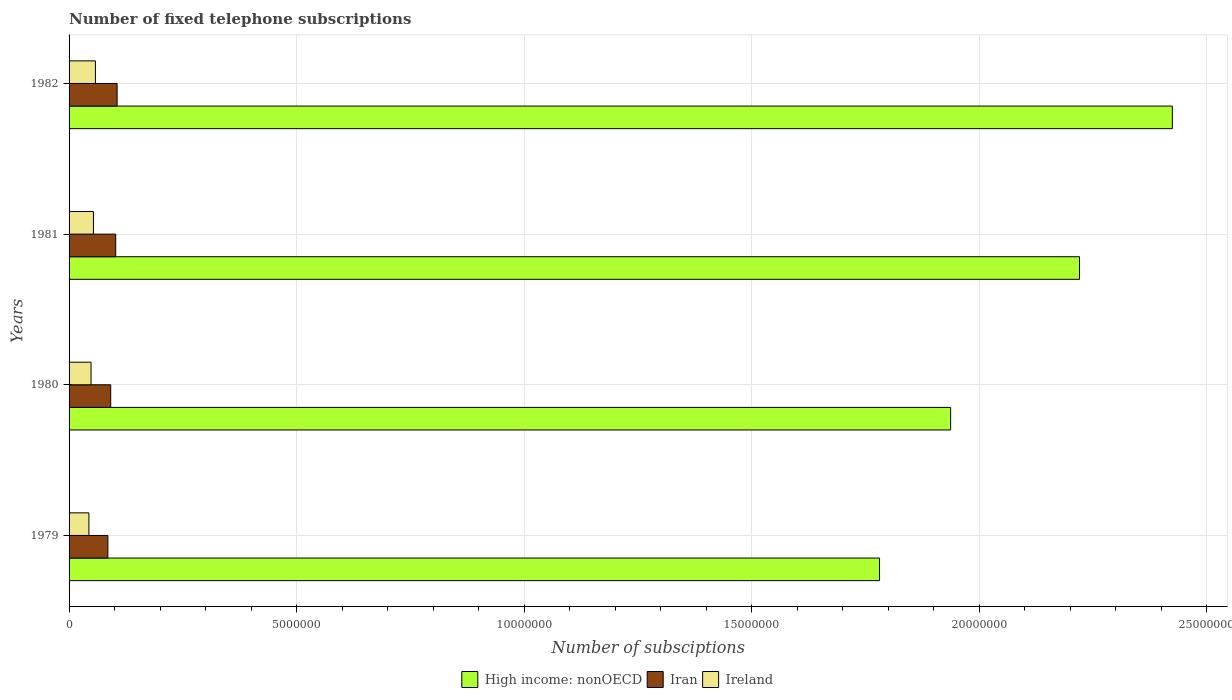How many different coloured bars are there?
Your answer should be compact. 3. Are the number of bars per tick equal to the number of legend labels?
Offer a very short reply. Yes. Are the number of bars on each tick of the Y-axis equal?
Offer a very short reply. Yes. How many bars are there on the 4th tick from the top?
Provide a succinct answer. 3. How many bars are there on the 3rd tick from the bottom?
Offer a terse response. 3. What is the label of the 4th group of bars from the top?
Provide a succinct answer. 1979. In how many cases, is the number of bars for a given year not equal to the number of legend labels?
Your answer should be very brief. 0. What is the number of fixed telephone subscriptions in High income: nonOECD in 1980?
Provide a succinct answer. 1.94e+07. Across all years, what is the maximum number of fixed telephone subscriptions in High income: nonOECD?
Provide a short and direct response. 2.42e+07. Across all years, what is the minimum number of fixed telephone subscriptions in High income: nonOECD?
Your answer should be very brief. 1.78e+07. In which year was the number of fixed telephone subscriptions in High income: nonOECD maximum?
Ensure brevity in your answer.  1982. In which year was the number of fixed telephone subscriptions in Iran minimum?
Keep it short and to the point. 1979. What is the total number of fixed telephone subscriptions in Ireland in the graph?
Your answer should be compact. 2.03e+06. What is the difference between the number of fixed telephone subscriptions in Ireland in 1981 and that in 1982?
Offer a terse response. -4.36e+04. What is the difference between the number of fixed telephone subscriptions in Iran in 1981 and the number of fixed telephone subscriptions in Ireland in 1979?
Offer a terse response. 5.89e+05. What is the average number of fixed telephone subscriptions in High income: nonOECD per year?
Keep it short and to the point. 2.09e+07. In the year 1980, what is the difference between the number of fixed telephone subscriptions in Ireland and number of fixed telephone subscriptions in High income: nonOECD?
Offer a terse response. -1.89e+07. What is the ratio of the number of fixed telephone subscriptions in Iran in 1981 to that in 1982?
Ensure brevity in your answer.  0.97. Is the number of fixed telephone subscriptions in Iran in 1980 less than that in 1981?
Keep it short and to the point. Yes. Is the difference between the number of fixed telephone subscriptions in Ireland in 1981 and 1982 greater than the difference between the number of fixed telephone subscriptions in High income: nonOECD in 1981 and 1982?
Give a very brief answer. Yes. What is the difference between the highest and the second highest number of fixed telephone subscriptions in Iran?
Your answer should be very brief. 3.07e+04. What is the difference between the highest and the lowest number of fixed telephone subscriptions in Iran?
Make the answer very short. 2.03e+05. In how many years, is the number of fixed telephone subscriptions in Iran greater than the average number of fixed telephone subscriptions in Iran taken over all years?
Give a very brief answer. 2. What does the 1st bar from the top in 1979 represents?
Make the answer very short. Ireland. What does the 3rd bar from the bottom in 1980 represents?
Provide a short and direct response. Ireland. Is it the case that in every year, the sum of the number of fixed telephone subscriptions in Iran and number of fixed telephone subscriptions in Ireland is greater than the number of fixed telephone subscriptions in High income: nonOECD?
Provide a short and direct response. No. How many bars are there?
Your response must be concise. 12. Are all the bars in the graph horizontal?
Ensure brevity in your answer.  Yes. What is the difference between two consecutive major ticks on the X-axis?
Make the answer very short. 5.00e+06. What is the title of the graph?
Keep it short and to the point. Number of fixed telephone subscriptions. Does "Montenegro" appear as one of the legend labels in the graph?
Keep it short and to the point. No. What is the label or title of the X-axis?
Your answer should be very brief. Number of subsciptions. What is the label or title of the Y-axis?
Provide a succinct answer. Years. What is the Number of subsciptions of High income: nonOECD in 1979?
Provide a short and direct response. 1.78e+07. What is the Number of subsciptions in Iran in 1979?
Your answer should be compact. 8.53e+05. What is the Number of subsciptions in Ireland in 1979?
Keep it short and to the point. 4.36e+05. What is the Number of subsciptions in High income: nonOECD in 1980?
Provide a succinct answer. 1.94e+07. What is the Number of subsciptions of Iran in 1980?
Your answer should be very brief. 9.15e+05. What is the Number of subsciptions in Ireland in 1980?
Your answer should be very brief. 4.83e+05. What is the Number of subsciptions in High income: nonOECD in 1981?
Keep it short and to the point. 2.22e+07. What is the Number of subsciptions of Iran in 1981?
Ensure brevity in your answer.  1.03e+06. What is the Number of subsciptions in Ireland in 1981?
Offer a terse response. 5.36e+05. What is the Number of subsciptions of High income: nonOECD in 1982?
Offer a terse response. 2.42e+07. What is the Number of subsciptions of Iran in 1982?
Provide a succinct answer. 1.06e+06. What is the Number of subsciptions of Ireland in 1982?
Your answer should be compact. 5.80e+05. Across all years, what is the maximum Number of subsciptions of High income: nonOECD?
Provide a succinct answer. 2.42e+07. Across all years, what is the maximum Number of subsciptions in Iran?
Your response must be concise. 1.06e+06. Across all years, what is the maximum Number of subsciptions of Ireland?
Provide a succinct answer. 5.80e+05. Across all years, what is the minimum Number of subsciptions of High income: nonOECD?
Keep it short and to the point. 1.78e+07. Across all years, what is the minimum Number of subsciptions in Iran?
Give a very brief answer. 8.53e+05. Across all years, what is the minimum Number of subsciptions of Ireland?
Ensure brevity in your answer.  4.36e+05. What is the total Number of subsciptions of High income: nonOECD in the graph?
Offer a very short reply. 8.36e+07. What is the total Number of subsciptions of Iran in the graph?
Provide a succinct answer. 3.85e+06. What is the total Number of subsciptions in Ireland in the graph?
Provide a succinct answer. 2.03e+06. What is the difference between the Number of subsciptions in High income: nonOECD in 1979 and that in 1980?
Ensure brevity in your answer.  -1.56e+06. What is the difference between the Number of subsciptions in Iran in 1979 and that in 1980?
Keep it short and to the point. -6.23e+04. What is the difference between the Number of subsciptions of Ireland in 1979 and that in 1980?
Provide a succinct answer. -4.70e+04. What is the difference between the Number of subsciptions of High income: nonOECD in 1979 and that in 1981?
Keep it short and to the point. -4.40e+06. What is the difference between the Number of subsciptions of Iran in 1979 and that in 1981?
Ensure brevity in your answer.  -1.72e+05. What is the difference between the Number of subsciptions in Ireland in 1979 and that in 1981?
Your answer should be very brief. -1.00e+05. What is the difference between the Number of subsciptions of High income: nonOECD in 1979 and that in 1982?
Your answer should be very brief. -6.44e+06. What is the difference between the Number of subsciptions of Iran in 1979 and that in 1982?
Ensure brevity in your answer.  -2.03e+05. What is the difference between the Number of subsciptions of Ireland in 1979 and that in 1982?
Give a very brief answer. -1.44e+05. What is the difference between the Number of subsciptions in High income: nonOECD in 1980 and that in 1981?
Make the answer very short. -2.83e+06. What is the difference between the Number of subsciptions of Iran in 1980 and that in 1981?
Your answer should be compact. -1.10e+05. What is the difference between the Number of subsciptions of Ireland in 1980 and that in 1981?
Your answer should be very brief. -5.30e+04. What is the difference between the Number of subsciptions of High income: nonOECD in 1980 and that in 1982?
Provide a short and direct response. -4.87e+06. What is the difference between the Number of subsciptions in Iran in 1980 and that in 1982?
Provide a short and direct response. -1.41e+05. What is the difference between the Number of subsciptions in Ireland in 1980 and that in 1982?
Provide a succinct answer. -9.66e+04. What is the difference between the Number of subsciptions of High income: nonOECD in 1981 and that in 1982?
Provide a succinct answer. -2.04e+06. What is the difference between the Number of subsciptions of Iran in 1981 and that in 1982?
Give a very brief answer. -3.07e+04. What is the difference between the Number of subsciptions of Ireland in 1981 and that in 1982?
Make the answer very short. -4.36e+04. What is the difference between the Number of subsciptions in High income: nonOECD in 1979 and the Number of subsciptions in Iran in 1980?
Your answer should be compact. 1.69e+07. What is the difference between the Number of subsciptions of High income: nonOECD in 1979 and the Number of subsciptions of Ireland in 1980?
Provide a short and direct response. 1.73e+07. What is the difference between the Number of subsciptions of Iran in 1979 and the Number of subsciptions of Ireland in 1980?
Your answer should be compact. 3.70e+05. What is the difference between the Number of subsciptions of High income: nonOECD in 1979 and the Number of subsciptions of Iran in 1981?
Keep it short and to the point. 1.68e+07. What is the difference between the Number of subsciptions of High income: nonOECD in 1979 and the Number of subsciptions of Ireland in 1981?
Your answer should be compact. 1.73e+07. What is the difference between the Number of subsciptions of Iran in 1979 and the Number of subsciptions of Ireland in 1981?
Make the answer very short. 3.17e+05. What is the difference between the Number of subsciptions of High income: nonOECD in 1979 and the Number of subsciptions of Iran in 1982?
Provide a succinct answer. 1.68e+07. What is the difference between the Number of subsciptions of High income: nonOECD in 1979 and the Number of subsciptions of Ireland in 1982?
Your response must be concise. 1.72e+07. What is the difference between the Number of subsciptions of Iran in 1979 and the Number of subsciptions of Ireland in 1982?
Provide a short and direct response. 2.73e+05. What is the difference between the Number of subsciptions of High income: nonOECD in 1980 and the Number of subsciptions of Iran in 1981?
Your answer should be very brief. 1.84e+07. What is the difference between the Number of subsciptions of High income: nonOECD in 1980 and the Number of subsciptions of Ireland in 1981?
Your answer should be compact. 1.88e+07. What is the difference between the Number of subsciptions of Iran in 1980 and the Number of subsciptions of Ireland in 1981?
Ensure brevity in your answer.  3.79e+05. What is the difference between the Number of subsciptions in High income: nonOECD in 1980 and the Number of subsciptions in Iran in 1982?
Your answer should be very brief. 1.83e+07. What is the difference between the Number of subsciptions in High income: nonOECD in 1980 and the Number of subsciptions in Ireland in 1982?
Provide a succinct answer. 1.88e+07. What is the difference between the Number of subsciptions of Iran in 1980 and the Number of subsciptions of Ireland in 1982?
Ensure brevity in your answer.  3.36e+05. What is the difference between the Number of subsciptions in High income: nonOECD in 1981 and the Number of subsciptions in Iran in 1982?
Provide a succinct answer. 2.12e+07. What is the difference between the Number of subsciptions in High income: nonOECD in 1981 and the Number of subsciptions in Ireland in 1982?
Your answer should be compact. 2.16e+07. What is the difference between the Number of subsciptions of Iran in 1981 and the Number of subsciptions of Ireland in 1982?
Give a very brief answer. 4.45e+05. What is the average Number of subsciptions in High income: nonOECD per year?
Your response must be concise. 2.09e+07. What is the average Number of subsciptions of Iran per year?
Provide a short and direct response. 9.62e+05. What is the average Number of subsciptions in Ireland per year?
Your response must be concise. 5.09e+05. In the year 1979, what is the difference between the Number of subsciptions in High income: nonOECD and Number of subsciptions in Iran?
Keep it short and to the point. 1.70e+07. In the year 1979, what is the difference between the Number of subsciptions of High income: nonOECD and Number of subsciptions of Ireland?
Give a very brief answer. 1.74e+07. In the year 1979, what is the difference between the Number of subsciptions of Iran and Number of subsciptions of Ireland?
Give a very brief answer. 4.17e+05. In the year 1980, what is the difference between the Number of subsciptions in High income: nonOECD and Number of subsciptions in Iran?
Ensure brevity in your answer.  1.85e+07. In the year 1980, what is the difference between the Number of subsciptions in High income: nonOECD and Number of subsciptions in Ireland?
Ensure brevity in your answer.  1.89e+07. In the year 1980, what is the difference between the Number of subsciptions in Iran and Number of subsciptions in Ireland?
Provide a short and direct response. 4.32e+05. In the year 1981, what is the difference between the Number of subsciptions of High income: nonOECD and Number of subsciptions of Iran?
Ensure brevity in your answer.  2.12e+07. In the year 1981, what is the difference between the Number of subsciptions in High income: nonOECD and Number of subsciptions in Ireland?
Provide a succinct answer. 2.17e+07. In the year 1981, what is the difference between the Number of subsciptions of Iran and Number of subsciptions of Ireland?
Make the answer very short. 4.89e+05. In the year 1982, what is the difference between the Number of subsciptions in High income: nonOECD and Number of subsciptions in Iran?
Offer a very short reply. 2.32e+07. In the year 1982, what is the difference between the Number of subsciptions in High income: nonOECD and Number of subsciptions in Ireland?
Make the answer very short. 2.37e+07. In the year 1982, what is the difference between the Number of subsciptions of Iran and Number of subsciptions of Ireland?
Keep it short and to the point. 4.76e+05. What is the ratio of the Number of subsciptions of High income: nonOECD in 1979 to that in 1980?
Provide a short and direct response. 0.92. What is the ratio of the Number of subsciptions in Iran in 1979 to that in 1980?
Ensure brevity in your answer.  0.93. What is the ratio of the Number of subsciptions in Ireland in 1979 to that in 1980?
Offer a very short reply. 0.9. What is the ratio of the Number of subsciptions in High income: nonOECD in 1979 to that in 1981?
Give a very brief answer. 0.8. What is the ratio of the Number of subsciptions of Iran in 1979 to that in 1981?
Provide a succinct answer. 0.83. What is the ratio of the Number of subsciptions in Ireland in 1979 to that in 1981?
Offer a very short reply. 0.81. What is the ratio of the Number of subsciptions in High income: nonOECD in 1979 to that in 1982?
Your answer should be very brief. 0.73. What is the ratio of the Number of subsciptions of Iran in 1979 to that in 1982?
Provide a short and direct response. 0.81. What is the ratio of the Number of subsciptions in Ireland in 1979 to that in 1982?
Offer a very short reply. 0.75. What is the ratio of the Number of subsciptions in High income: nonOECD in 1980 to that in 1981?
Your answer should be compact. 0.87. What is the ratio of the Number of subsciptions in Iran in 1980 to that in 1981?
Offer a terse response. 0.89. What is the ratio of the Number of subsciptions in Ireland in 1980 to that in 1981?
Provide a short and direct response. 0.9. What is the ratio of the Number of subsciptions in High income: nonOECD in 1980 to that in 1982?
Your answer should be compact. 0.8. What is the ratio of the Number of subsciptions of Iran in 1980 to that in 1982?
Ensure brevity in your answer.  0.87. What is the ratio of the Number of subsciptions of High income: nonOECD in 1981 to that in 1982?
Offer a very short reply. 0.92. What is the ratio of the Number of subsciptions of Iran in 1981 to that in 1982?
Give a very brief answer. 0.97. What is the ratio of the Number of subsciptions of Ireland in 1981 to that in 1982?
Provide a succinct answer. 0.92. What is the difference between the highest and the second highest Number of subsciptions in High income: nonOECD?
Your answer should be compact. 2.04e+06. What is the difference between the highest and the second highest Number of subsciptions in Iran?
Keep it short and to the point. 3.07e+04. What is the difference between the highest and the second highest Number of subsciptions of Ireland?
Your answer should be very brief. 4.36e+04. What is the difference between the highest and the lowest Number of subsciptions in High income: nonOECD?
Offer a very short reply. 6.44e+06. What is the difference between the highest and the lowest Number of subsciptions in Iran?
Provide a succinct answer. 2.03e+05. What is the difference between the highest and the lowest Number of subsciptions in Ireland?
Your answer should be very brief. 1.44e+05. 